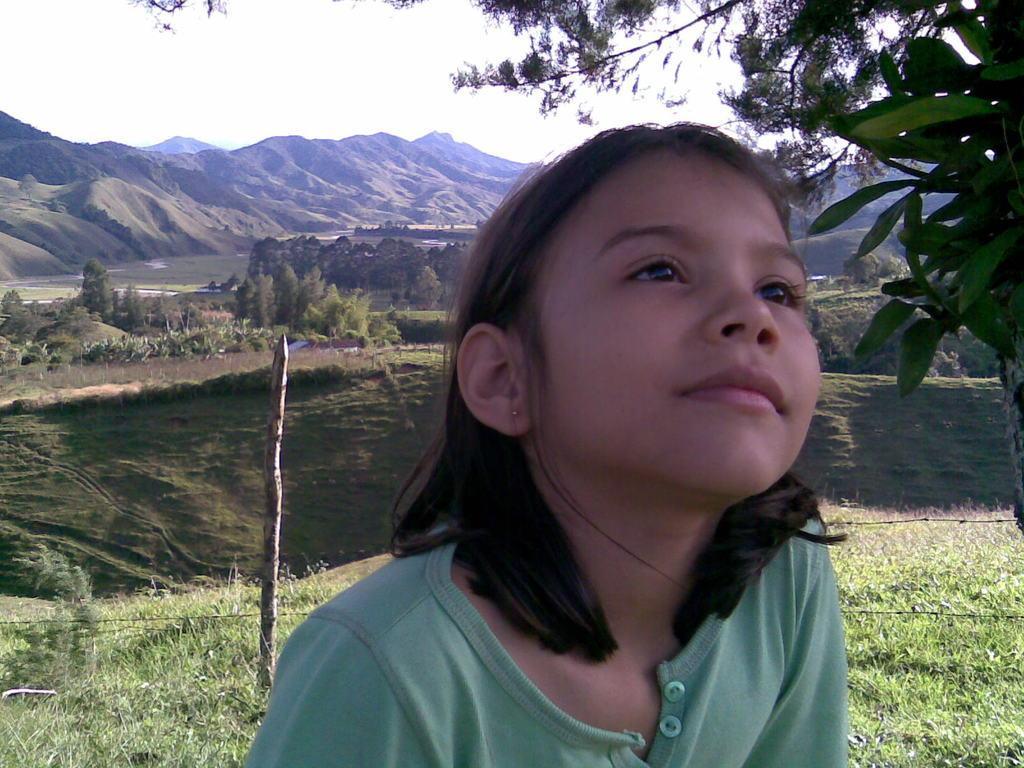Could you give a brief overview of what you see in this image? In this picture I can observe a girl wearing green color T shirt. On the left side I can observe a pole. In the background there are trees, hills and sky. 